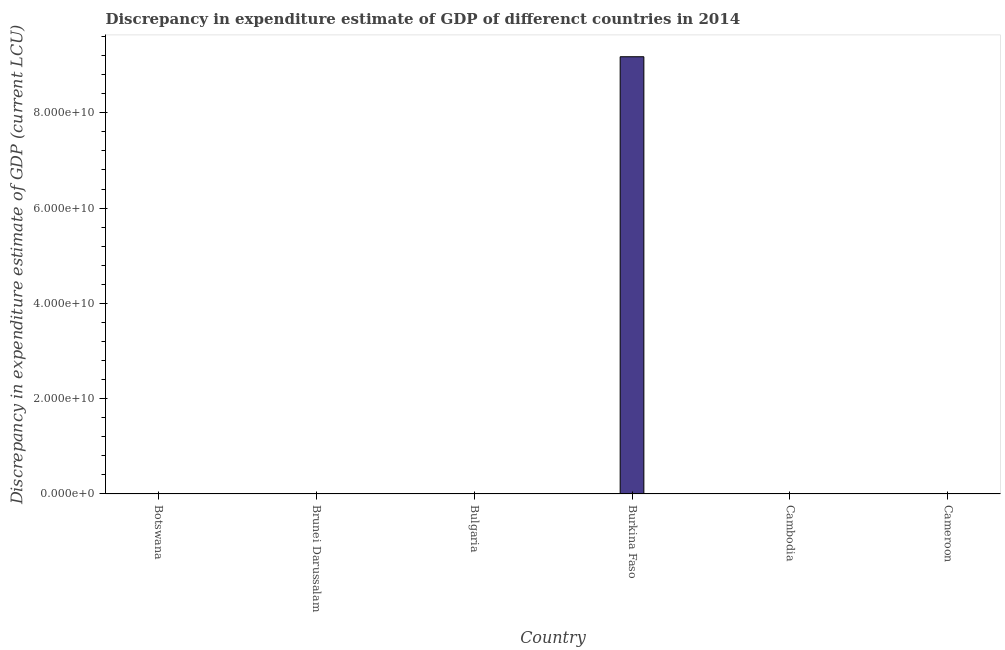What is the title of the graph?
Provide a short and direct response. Discrepancy in expenditure estimate of GDP of differenct countries in 2014. What is the label or title of the X-axis?
Provide a short and direct response. Country. What is the label or title of the Y-axis?
Your answer should be compact. Discrepancy in expenditure estimate of GDP (current LCU). What is the discrepancy in expenditure estimate of gdp in Brunei Darussalam?
Give a very brief answer. 4.22e+07. Across all countries, what is the maximum discrepancy in expenditure estimate of gdp?
Your response must be concise. 9.18e+1. In which country was the discrepancy in expenditure estimate of gdp maximum?
Keep it short and to the point. Burkina Faso. What is the sum of the discrepancy in expenditure estimate of gdp?
Give a very brief answer. 9.18e+1. What is the difference between the discrepancy in expenditure estimate of gdp in Brunei Darussalam and Burkina Faso?
Keep it short and to the point. -9.17e+1. What is the average discrepancy in expenditure estimate of gdp per country?
Make the answer very short. 1.53e+1. What is the median discrepancy in expenditure estimate of gdp?
Provide a short and direct response. 1.15e-5. What is the difference between the highest and the second highest discrepancy in expenditure estimate of gdp?
Your answer should be compact. 9.17e+1. What is the difference between the highest and the lowest discrepancy in expenditure estimate of gdp?
Provide a short and direct response. 9.18e+1. In how many countries, is the discrepancy in expenditure estimate of gdp greater than the average discrepancy in expenditure estimate of gdp taken over all countries?
Your answer should be compact. 1. How many bars are there?
Keep it short and to the point. 3. How many countries are there in the graph?
Make the answer very short. 6. What is the Discrepancy in expenditure estimate of GDP (current LCU) of Botswana?
Provide a short and direct response. 0. What is the Discrepancy in expenditure estimate of GDP (current LCU) of Brunei Darussalam?
Your response must be concise. 4.22e+07. What is the Discrepancy in expenditure estimate of GDP (current LCU) of Bulgaria?
Your answer should be compact. 2.3e-5. What is the Discrepancy in expenditure estimate of GDP (current LCU) of Burkina Faso?
Offer a very short reply. 9.18e+1. What is the difference between the Discrepancy in expenditure estimate of GDP (current LCU) in Brunei Darussalam and Bulgaria?
Offer a very short reply. 4.22e+07. What is the difference between the Discrepancy in expenditure estimate of GDP (current LCU) in Brunei Darussalam and Burkina Faso?
Give a very brief answer. -9.17e+1. What is the difference between the Discrepancy in expenditure estimate of GDP (current LCU) in Bulgaria and Burkina Faso?
Your answer should be compact. -9.18e+1. What is the ratio of the Discrepancy in expenditure estimate of GDP (current LCU) in Brunei Darussalam to that in Bulgaria?
Make the answer very short. 1.83e+12. What is the ratio of the Discrepancy in expenditure estimate of GDP (current LCU) in Brunei Darussalam to that in Burkina Faso?
Give a very brief answer. 0. What is the ratio of the Discrepancy in expenditure estimate of GDP (current LCU) in Bulgaria to that in Burkina Faso?
Keep it short and to the point. 0. 